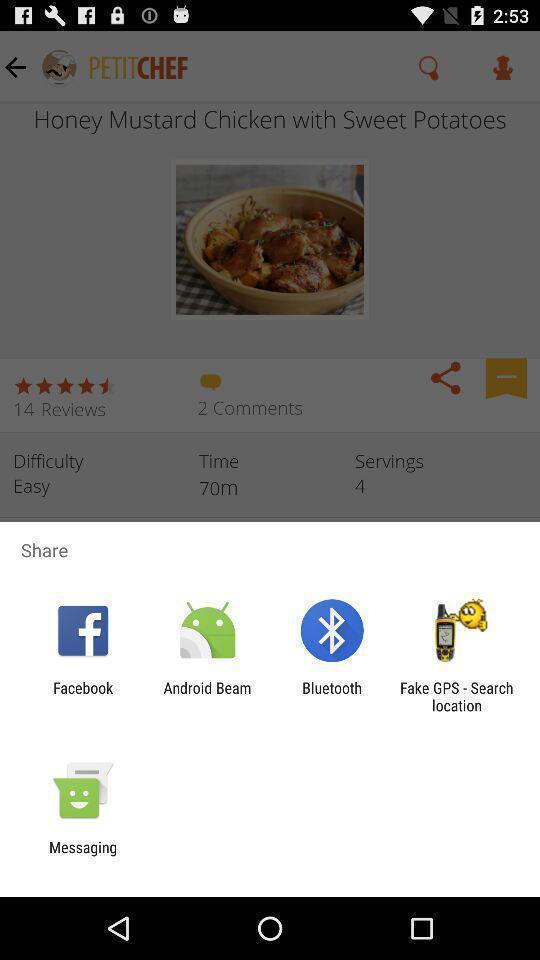Describe this image in words. Pop-up showing sharing options on recipes app. 